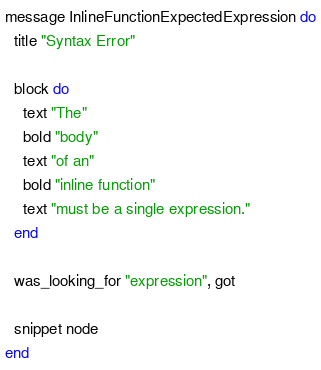Convert code to text. <code><loc_0><loc_0><loc_500><loc_500><_Crystal_>message InlineFunctionExpectedExpression do
  title "Syntax Error"

  block do
    text "The"
    bold "body"
    text "of an"
    bold "inline function"
    text "must be a single expression."
  end

  was_looking_for "expression", got

  snippet node
end
</code> 